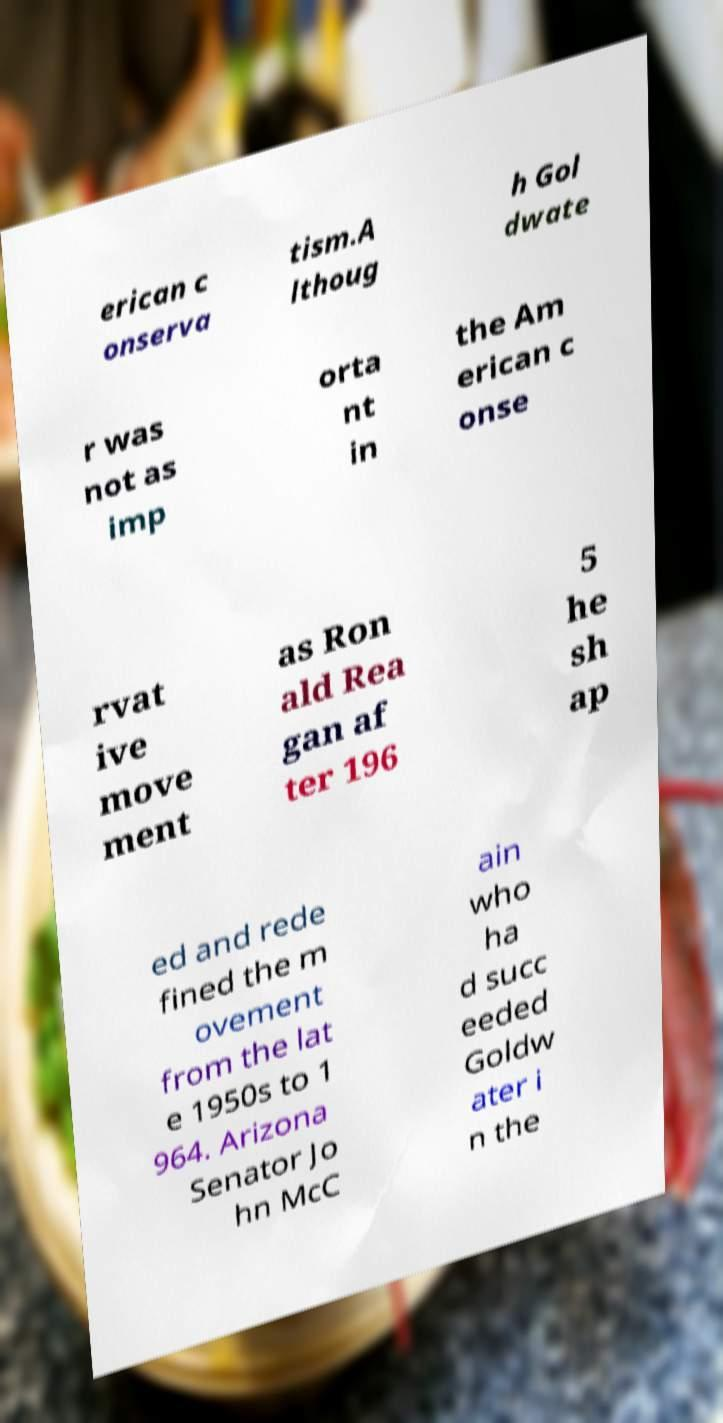Could you assist in decoding the text presented in this image and type it out clearly? erican c onserva tism.A lthoug h Gol dwate r was not as imp orta nt in the Am erican c onse rvat ive move ment as Ron ald Rea gan af ter 196 5 he sh ap ed and rede fined the m ovement from the lat e 1950s to 1 964. Arizona Senator Jo hn McC ain who ha d succ eeded Goldw ater i n the 